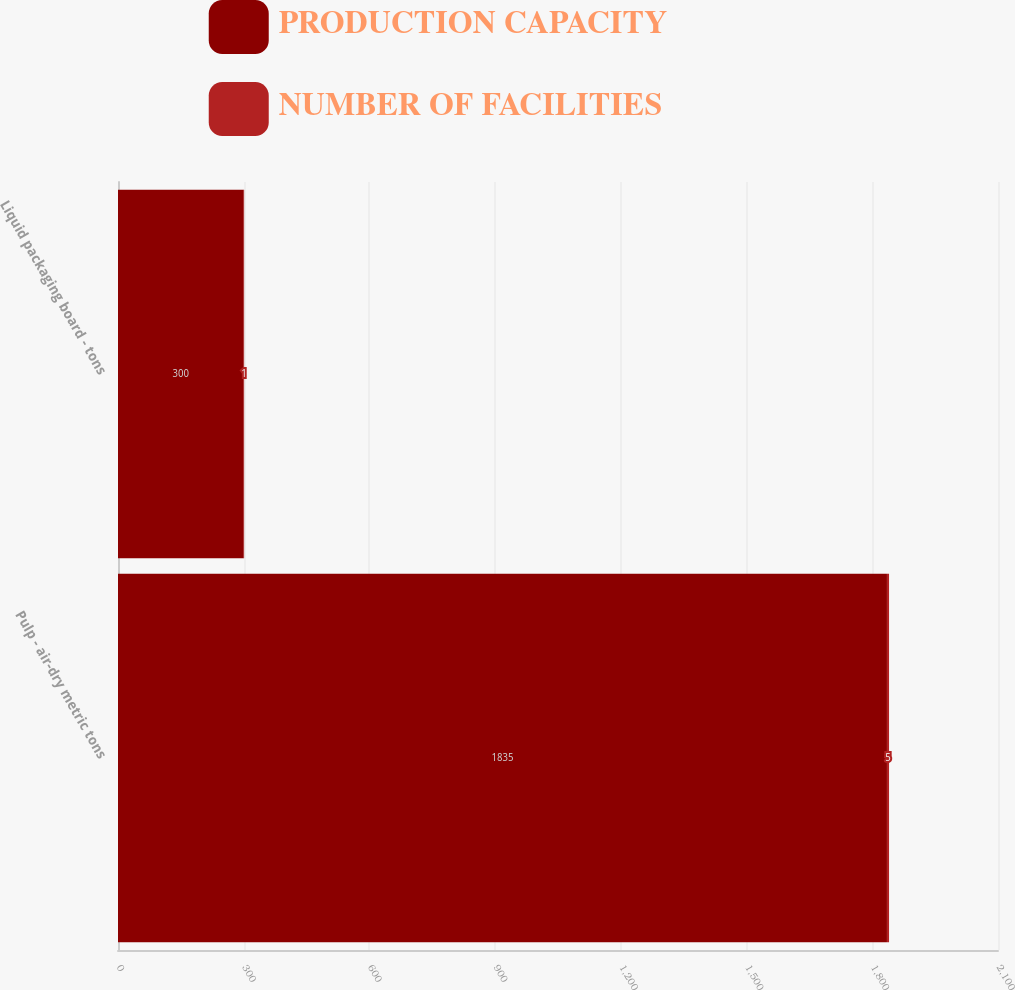Convert chart to OTSL. <chart><loc_0><loc_0><loc_500><loc_500><stacked_bar_chart><ecel><fcel>Pulp - air-dry metric tons<fcel>Liquid packaging board - tons<nl><fcel>PRODUCTION CAPACITY<fcel>1835<fcel>300<nl><fcel>NUMBER OF FACILITIES<fcel>5<fcel>1<nl></chart> 